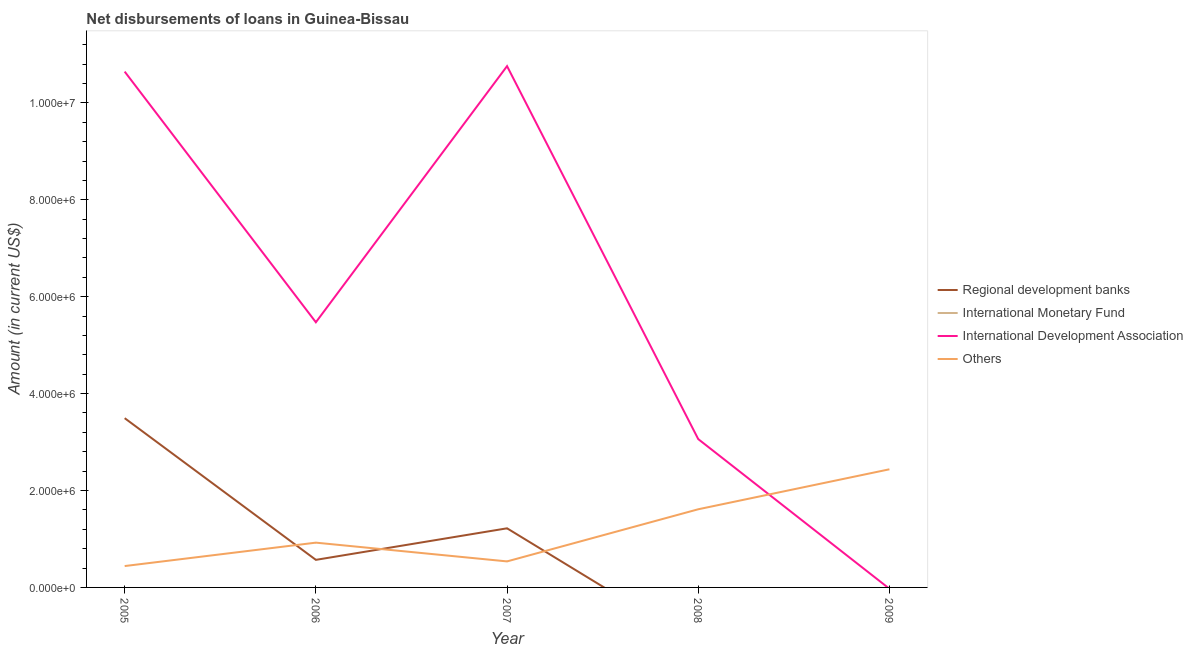What is the amount of loan disimbursed by international development association in 2008?
Offer a very short reply. 3.06e+06. Across all years, what is the maximum amount of loan disimbursed by international development association?
Your answer should be very brief. 1.08e+07. Across all years, what is the minimum amount of loan disimbursed by international development association?
Your response must be concise. 0. In which year was the amount of loan disimbursed by other organisations maximum?
Your response must be concise. 2009. What is the difference between the amount of loan disimbursed by other organisations in 2005 and that in 2008?
Make the answer very short. -1.17e+06. What is the difference between the amount of loan disimbursed by other organisations in 2009 and the amount of loan disimbursed by international development association in 2008?
Keep it short and to the point. -6.23e+05. What is the average amount of loan disimbursed by regional development banks per year?
Your answer should be compact. 1.06e+06. In the year 2006, what is the difference between the amount of loan disimbursed by other organisations and amount of loan disimbursed by regional development banks?
Offer a very short reply. 3.55e+05. In how many years, is the amount of loan disimbursed by regional development banks greater than 2800000 US$?
Ensure brevity in your answer.  1. What is the ratio of the amount of loan disimbursed by other organisations in 2005 to that in 2009?
Provide a succinct answer. 0.18. Is the amount of loan disimbursed by international development association in 2005 less than that in 2008?
Ensure brevity in your answer.  No. What is the difference between the highest and the second highest amount of loan disimbursed by other organisations?
Your response must be concise. 8.25e+05. What is the difference between the highest and the lowest amount of loan disimbursed by international development association?
Ensure brevity in your answer.  1.08e+07. Is the sum of the amount of loan disimbursed by international development association in 2005 and 2006 greater than the maximum amount of loan disimbursed by other organisations across all years?
Offer a very short reply. Yes. Is it the case that in every year, the sum of the amount of loan disimbursed by regional development banks and amount of loan disimbursed by other organisations is greater than the sum of amount of loan disimbursed by international monetary fund and amount of loan disimbursed by international development association?
Your answer should be compact. Yes. How many years are there in the graph?
Your response must be concise. 5. Are the values on the major ticks of Y-axis written in scientific E-notation?
Ensure brevity in your answer.  Yes. Does the graph contain any zero values?
Your answer should be very brief. Yes. Where does the legend appear in the graph?
Make the answer very short. Center right. What is the title of the graph?
Your answer should be compact. Net disbursements of loans in Guinea-Bissau. What is the label or title of the Y-axis?
Provide a short and direct response. Amount (in current US$). What is the Amount (in current US$) of Regional development banks in 2005?
Provide a short and direct response. 3.49e+06. What is the Amount (in current US$) of International Development Association in 2005?
Keep it short and to the point. 1.06e+07. What is the Amount (in current US$) of Others in 2005?
Your answer should be compact. 4.41e+05. What is the Amount (in current US$) in Regional development banks in 2006?
Your answer should be compact. 5.69e+05. What is the Amount (in current US$) of International Monetary Fund in 2006?
Offer a very short reply. 0. What is the Amount (in current US$) of International Development Association in 2006?
Your answer should be very brief. 5.47e+06. What is the Amount (in current US$) of Others in 2006?
Provide a succinct answer. 9.24e+05. What is the Amount (in current US$) in Regional development banks in 2007?
Provide a short and direct response. 1.22e+06. What is the Amount (in current US$) of International Development Association in 2007?
Your response must be concise. 1.08e+07. What is the Amount (in current US$) of Others in 2007?
Keep it short and to the point. 5.37e+05. What is the Amount (in current US$) in Regional development banks in 2008?
Give a very brief answer. 0. What is the Amount (in current US$) of International Monetary Fund in 2008?
Keep it short and to the point. 0. What is the Amount (in current US$) of International Development Association in 2008?
Make the answer very short. 3.06e+06. What is the Amount (in current US$) in Others in 2008?
Offer a terse response. 1.61e+06. What is the Amount (in current US$) of Regional development banks in 2009?
Ensure brevity in your answer.  0. What is the Amount (in current US$) of International Monetary Fund in 2009?
Your answer should be very brief. 0. What is the Amount (in current US$) of International Development Association in 2009?
Make the answer very short. 0. What is the Amount (in current US$) of Others in 2009?
Provide a succinct answer. 2.44e+06. Across all years, what is the maximum Amount (in current US$) in Regional development banks?
Give a very brief answer. 3.49e+06. Across all years, what is the maximum Amount (in current US$) in International Development Association?
Ensure brevity in your answer.  1.08e+07. Across all years, what is the maximum Amount (in current US$) of Others?
Keep it short and to the point. 2.44e+06. Across all years, what is the minimum Amount (in current US$) of Regional development banks?
Make the answer very short. 0. Across all years, what is the minimum Amount (in current US$) in Others?
Your answer should be very brief. 4.41e+05. What is the total Amount (in current US$) in Regional development banks in the graph?
Your response must be concise. 5.28e+06. What is the total Amount (in current US$) of International Development Association in the graph?
Your answer should be very brief. 2.99e+07. What is the total Amount (in current US$) of Others in the graph?
Offer a very short reply. 5.95e+06. What is the difference between the Amount (in current US$) of Regional development banks in 2005 and that in 2006?
Your answer should be compact. 2.92e+06. What is the difference between the Amount (in current US$) of International Development Association in 2005 and that in 2006?
Your answer should be compact. 5.17e+06. What is the difference between the Amount (in current US$) in Others in 2005 and that in 2006?
Provide a short and direct response. -4.83e+05. What is the difference between the Amount (in current US$) of Regional development banks in 2005 and that in 2007?
Offer a terse response. 2.27e+06. What is the difference between the Amount (in current US$) of International Development Association in 2005 and that in 2007?
Offer a very short reply. -1.13e+05. What is the difference between the Amount (in current US$) of Others in 2005 and that in 2007?
Provide a short and direct response. -9.60e+04. What is the difference between the Amount (in current US$) in International Development Association in 2005 and that in 2008?
Keep it short and to the point. 7.58e+06. What is the difference between the Amount (in current US$) in Others in 2005 and that in 2008?
Provide a succinct answer. -1.17e+06. What is the difference between the Amount (in current US$) of Others in 2005 and that in 2009?
Your answer should be compact. -2.00e+06. What is the difference between the Amount (in current US$) in Regional development banks in 2006 and that in 2007?
Your answer should be compact. -6.51e+05. What is the difference between the Amount (in current US$) in International Development Association in 2006 and that in 2007?
Make the answer very short. -5.29e+06. What is the difference between the Amount (in current US$) of Others in 2006 and that in 2007?
Offer a terse response. 3.87e+05. What is the difference between the Amount (in current US$) of International Development Association in 2006 and that in 2008?
Offer a very short reply. 2.41e+06. What is the difference between the Amount (in current US$) in Others in 2006 and that in 2008?
Give a very brief answer. -6.89e+05. What is the difference between the Amount (in current US$) of Others in 2006 and that in 2009?
Give a very brief answer. -1.51e+06. What is the difference between the Amount (in current US$) of International Development Association in 2007 and that in 2008?
Provide a succinct answer. 7.70e+06. What is the difference between the Amount (in current US$) of Others in 2007 and that in 2008?
Provide a succinct answer. -1.08e+06. What is the difference between the Amount (in current US$) in Others in 2007 and that in 2009?
Offer a very short reply. -1.90e+06. What is the difference between the Amount (in current US$) of Others in 2008 and that in 2009?
Provide a succinct answer. -8.25e+05. What is the difference between the Amount (in current US$) of Regional development banks in 2005 and the Amount (in current US$) of International Development Association in 2006?
Ensure brevity in your answer.  -1.98e+06. What is the difference between the Amount (in current US$) in Regional development banks in 2005 and the Amount (in current US$) in Others in 2006?
Ensure brevity in your answer.  2.57e+06. What is the difference between the Amount (in current US$) in International Development Association in 2005 and the Amount (in current US$) in Others in 2006?
Keep it short and to the point. 9.72e+06. What is the difference between the Amount (in current US$) in Regional development banks in 2005 and the Amount (in current US$) in International Development Association in 2007?
Provide a short and direct response. -7.26e+06. What is the difference between the Amount (in current US$) in Regional development banks in 2005 and the Amount (in current US$) in Others in 2007?
Your answer should be compact. 2.96e+06. What is the difference between the Amount (in current US$) of International Development Association in 2005 and the Amount (in current US$) of Others in 2007?
Provide a succinct answer. 1.01e+07. What is the difference between the Amount (in current US$) in Regional development banks in 2005 and the Amount (in current US$) in International Development Association in 2008?
Offer a terse response. 4.32e+05. What is the difference between the Amount (in current US$) of Regional development banks in 2005 and the Amount (in current US$) of Others in 2008?
Give a very brief answer. 1.88e+06. What is the difference between the Amount (in current US$) in International Development Association in 2005 and the Amount (in current US$) in Others in 2008?
Keep it short and to the point. 9.03e+06. What is the difference between the Amount (in current US$) in Regional development banks in 2005 and the Amount (in current US$) in Others in 2009?
Give a very brief answer. 1.06e+06. What is the difference between the Amount (in current US$) in International Development Association in 2005 and the Amount (in current US$) in Others in 2009?
Your answer should be compact. 8.21e+06. What is the difference between the Amount (in current US$) of Regional development banks in 2006 and the Amount (in current US$) of International Development Association in 2007?
Your answer should be compact. -1.02e+07. What is the difference between the Amount (in current US$) in Regional development banks in 2006 and the Amount (in current US$) in Others in 2007?
Ensure brevity in your answer.  3.20e+04. What is the difference between the Amount (in current US$) of International Development Association in 2006 and the Amount (in current US$) of Others in 2007?
Ensure brevity in your answer.  4.94e+06. What is the difference between the Amount (in current US$) of Regional development banks in 2006 and the Amount (in current US$) of International Development Association in 2008?
Your response must be concise. -2.49e+06. What is the difference between the Amount (in current US$) in Regional development banks in 2006 and the Amount (in current US$) in Others in 2008?
Offer a terse response. -1.04e+06. What is the difference between the Amount (in current US$) in International Development Association in 2006 and the Amount (in current US$) in Others in 2008?
Provide a succinct answer. 3.86e+06. What is the difference between the Amount (in current US$) of Regional development banks in 2006 and the Amount (in current US$) of Others in 2009?
Keep it short and to the point. -1.87e+06. What is the difference between the Amount (in current US$) in International Development Association in 2006 and the Amount (in current US$) in Others in 2009?
Your answer should be compact. 3.03e+06. What is the difference between the Amount (in current US$) in Regional development banks in 2007 and the Amount (in current US$) in International Development Association in 2008?
Provide a succinct answer. -1.84e+06. What is the difference between the Amount (in current US$) of Regional development banks in 2007 and the Amount (in current US$) of Others in 2008?
Make the answer very short. -3.93e+05. What is the difference between the Amount (in current US$) of International Development Association in 2007 and the Amount (in current US$) of Others in 2008?
Your response must be concise. 9.14e+06. What is the difference between the Amount (in current US$) in Regional development banks in 2007 and the Amount (in current US$) in Others in 2009?
Your answer should be very brief. -1.22e+06. What is the difference between the Amount (in current US$) in International Development Association in 2007 and the Amount (in current US$) in Others in 2009?
Keep it short and to the point. 8.32e+06. What is the difference between the Amount (in current US$) of International Development Association in 2008 and the Amount (in current US$) of Others in 2009?
Your answer should be very brief. 6.23e+05. What is the average Amount (in current US$) of Regional development banks per year?
Ensure brevity in your answer.  1.06e+06. What is the average Amount (in current US$) in International Monetary Fund per year?
Your answer should be compact. 0. What is the average Amount (in current US$) in International Development Association per year?
Keep it short and to the point. 5.99e+06. What is the average Amount (in current US$) in Others per year?
Keep it short and to the point. 1.19e+06. In the year 2005, what is the difference between the Amount (in current US$) in Regional development banks and Amount (in current US$) in International Development Association?
Your response must be concise. -7.15e+06. In the year 2005, what is the difference between the Amount (in current US$) of Regional development banks and Amount (in current US$) of Others?
Ensure brevity in your answer.  3.05e+06. In the year 2005, what is the difference between the Amount (in current US$) of International Development Association and Amount (in current US$) of Others?
Your response must be concise. 1.02e+07. In the year 2006, what is the difference between the Amount (in current US$) of Regional development banks and Amount (in current US$) of International Development Association?
Keep it short and to the point. -4.90e+06. In the year 2006, what is the difference between the Amount (in current US$) in Regional development banks and Amount (in current US$) in Others?
Provide a short and direct response. -3.55e+05. In the year 2006, what is the difference between the Amount (in current US$) of International Development Association and Amount (in current US$) of Others?
Offer a terse response. 4.55e+06. In the year 2007, what is the difference between the Amount (in current US$) in Regional development banks and Amount (in current US$) in International Development Association?
Provide a succinct answer. -9.54e+06. In the year 2007, what is the difference between the Amount (in current US$) in Regional development banks and Amount (in current US$) in Others?
Your answer should be very brief. 6.83e+05. In the year 2007, what is the difference between the Amount (in current US$) in International Development Association and Amount (in current US$) in Others?
Offer a very short reply. 1.02e+07. In the year 2008, what is the difference between the Amount (in current US$) of International Development Association and Amount (in current US$) of Others?
Keep it short and to the point. 1.45e+06. What is the ratio of the Amount (in current US$) of Regional development banks in 2005 to that in 2006?
Provide a short and direct response. 6.14. What is the ratio of the Amount (in current US$) in International Development Association in 2005 to that in 2006?
Offer a very short reply. 1.95. What is the ratio of the Amount (in current US$) of Others in 2005 to that in 2006?
Your response must be concise. 0.48. What is the ratio of the Amount (in current US$) of Regional development banks in 2005 to that in 2007?
Make the answer very short. 2.86. What is the ratio of the Amount (in current US$) of Others in 2005 to that in 2007?
Your answer should be very brief. 0.82. What is the ratio of the Amount (in current US$) of International Development Association in 2005 to that in 2008?
Give a very brief answer. 3.48. What is the ratio of the Amount (in current US$) in Others in 2005 to that in 2008?
Provide a short and direct response. 0.27. What is the ratio of the Amount (in current US$) of Others in 2005 to that in 2009?
Provide a short and direct response. 0.18. What is the ratio of the Amount (in current US$) of Regional development banks in 2006 to that in 2007?
Offer a terse response. 0.47. What is the ratio of the Amount (in current US$) in International Development Association in 2006 to that in 2007?
Provide a succinct answer. 0.51. What is the ratio of the Amount (in current US$) of Others in 2006 to that in 2007?
Provide a succinct answer. 1.72. What is the ratio of the Amount (in current US$) of International Development Association in 2006 to that in 2008?
Provide a short and direct response. 1.79. What is the ratio of the Amount (in current US$) of Others in 2006 to that in 2008?
Ensure brevity in your answer.  0.57. What is the ratio of the Amount (in current US$) of Others in 2006 to that in 2009?
Offer a terse response. 0.38. What is the ratio of the Amount (in current US$) of International Development Association in 2007 to that in 2008?
Your answer should be very brief. 3.51. What is the ratio of the Amount (in current US$) in Others in 2007 to that in 2008?
Your answer should be compact. 0.33. What is the ratio of the Amount (in current US$) of Others in 2007 to that in 2009?
Provide a succinct answer. 0.22. What is the ratio of the Amount (in current US$) of Others in 2008 to that in 2009?
Give a very brief answer. 0.66. What is the difference between the highest and the second highest Amount (in current US$) of Regional development banks?
Offer a terse response. 2.27e+06. What is the difference between the highest and the second highest Amount (in current US$) in International Development Association?
Offer a very short reply. 1.13e+05. What is the difference between the highest and the second highest Amount (in current US$) in Others?
Ensure brevity in your answer.  8.25e+05. What is the difference between the highest and the lowest Amount (in current US$) in Regional development banks?
Offer a terse response. 3.49e+06. What is the difference between the highest and the lowest Amount (in current US$) of International Development Association?
Keep it short and to the point. 1.08e+07. What is the difference between the highest and the lowest Amount (in current US$) of Others?
Make the answer very short. 2.00e+06. 